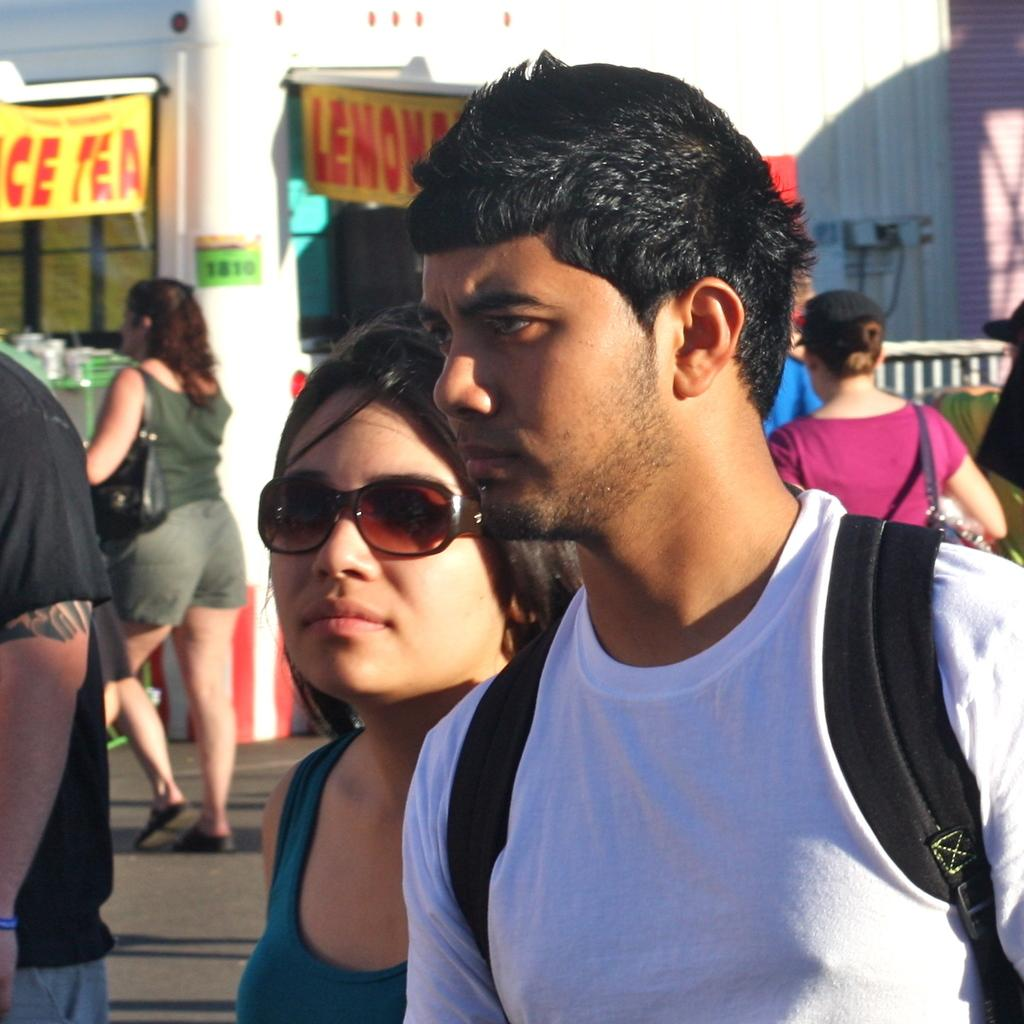Who or what can be seen in the image? There are people in the image. What is the banner in the image used for? The purpose of the banner in the image is not specified, but it is likely for an event or announcement. What is the fence in the image used for? The fence in the image is likely used for separating or enclosing an area. What type of houses can be seen in the background of the image? There are no houses visible in the image; it only features people, a banner, and a fence. 